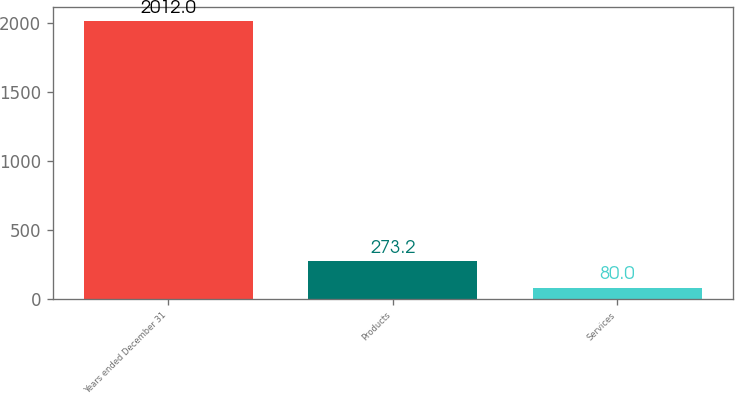Convert chart to OTSL. <chart><loc_0><loc_0><loc_500><loc_500><bar_chart><fcel>Years ended December 31<fcel>Products<fcel>Services<nl><fcel>2012<fcel>273.2<fcel>80<nl></chart> 